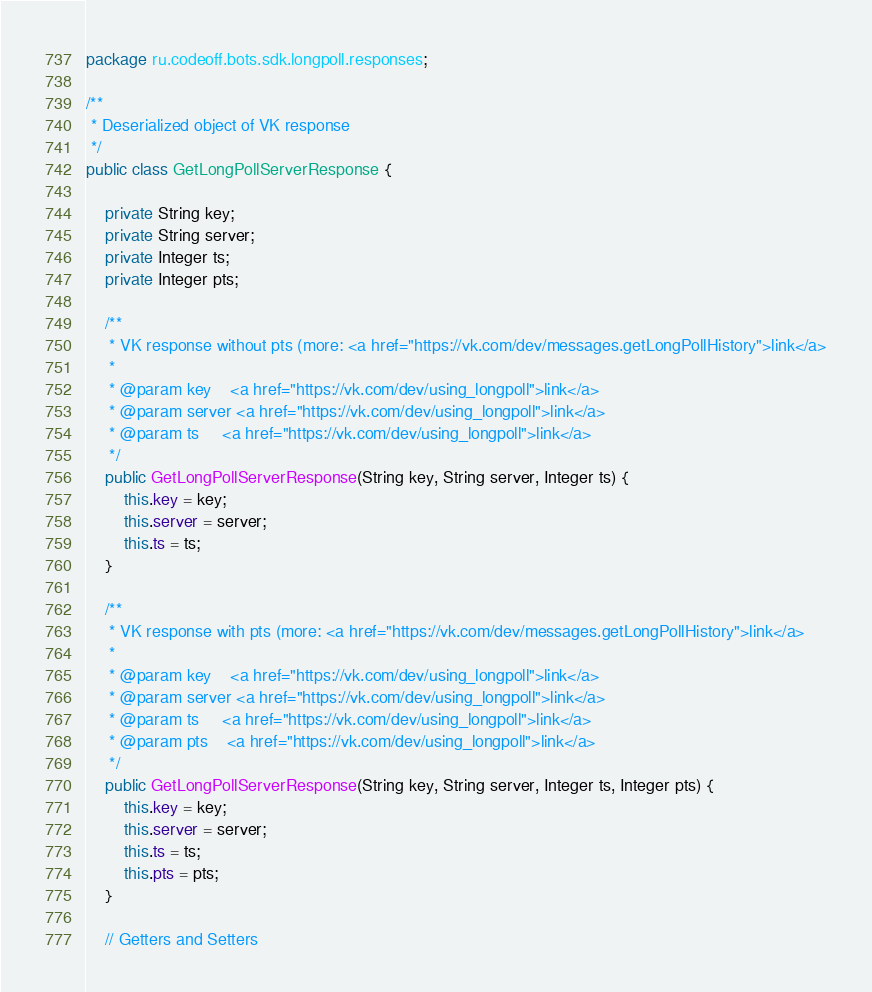Convert code to text. <code><loc_0><loc_0><loc_500><loc_500><_Java_>package ru.codeoff.bots.sdk.longpoll.responses;

/**
 * Deserialized object of VK response
 */
public class GetLongPollServerResponse {

    private String key;
    private String server;
    private Integer ts;
    private Integer pts;

    /**
     * VK response without pts (more: <a href="https://vk.com/dev/messages.getLongPollHistory">link</a>
     *
     * @param key    <a href="https://vk.com/dev/using_longpoll">link</a>
     * @param server <a href="https://vk.com/dev/using_longpoll">link</a>
     * @param ts     <a href="https://vk.com/dev/using_longpoll">link</a>
     */
    public GetLongPollServerResponse(String key, String server, Integer ts) {
        this.key = key;
        this.server = server;
        this.ts = ts;
    }

    /**
     * VK response with pts (more: <a href="https://vk.com/dev/messages.getLongPollHistory">link</a>
     *
     * @param key    <a href="https://vk.com/dev/using_longpoll">link</a>
     * @param server <a href="https://vk.com/dev/using_longpoll">link</a>
     * @param ts     <a href="https://vk.com/dev/using_longpoll">link</a>
     * @param pts    <a href="https://vk.com/dev/using_longpoll">link</a>
     */
    public GetLongPollServerResponse(String key, String server, Integer ts, Integer pts) {
        this.key = key;
        this.server = server;
        this.ts = ts;
        this.pts = pts;
    }

    // Getters and Setters
</code> 